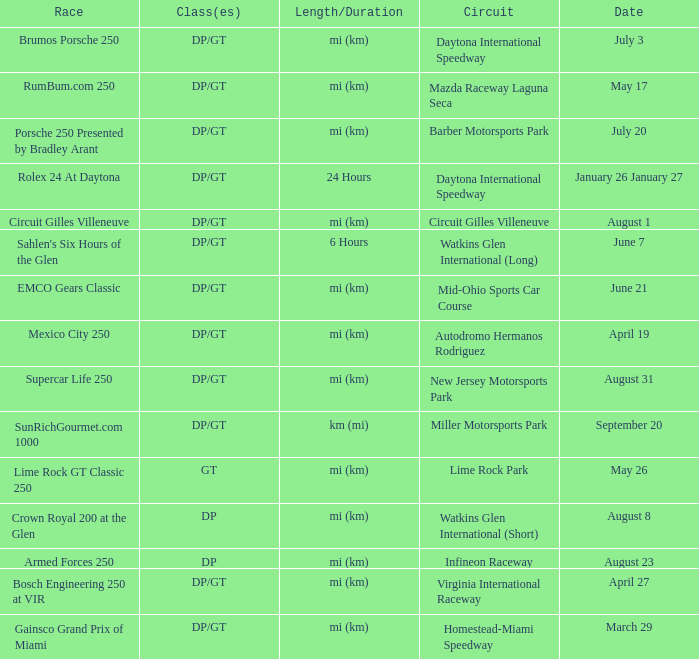What was the circuit had a race on September 20. Miller Motorsports Park. 